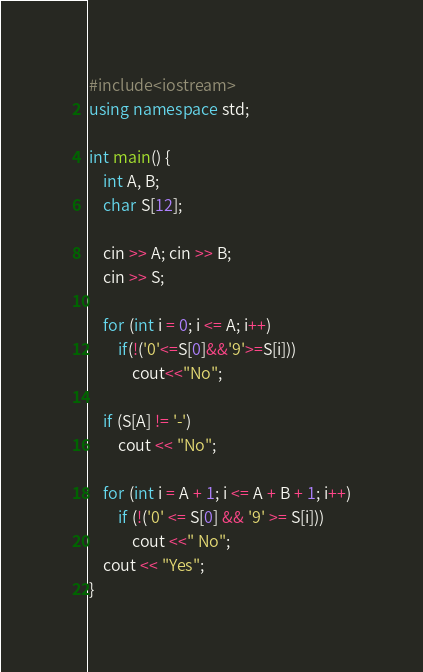<code> <loc_0><loc_0><loc_500><loc_500><_C++_>#include<iostream>
using namespace std;

int main() {
	int A, B;
	char S[12];
	
	cin >> A; cin >> B;
	cin >> S;

	for (int i = 0; i <= A; i++)
		if(!('0'<=S[0]&&'9'>=S[i]))
			cout<<"No";

	if (S[A] != '-')
		cout << "No";

	for (int i = A + 1; i <= A + B + 1; i++)
		if (!('0' <= S[0] && '9' >= S[i]))
			cout <<" No";
	cout << "Yes";
}	</code> 